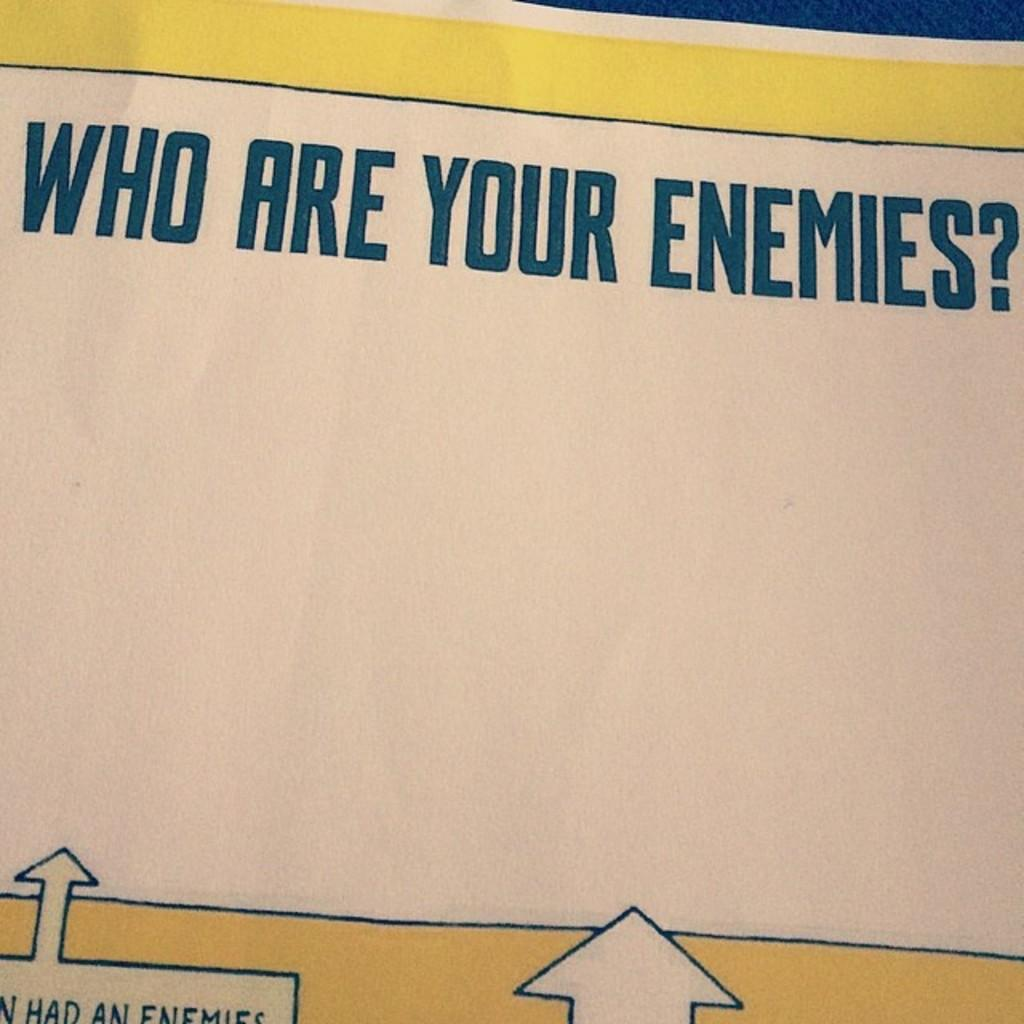<image>
Describe the image concisely. A poster asks the question "who are your enemies?" 